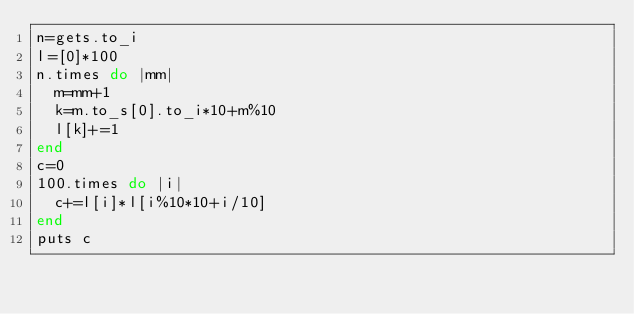<code> <loc_0><loc_0><loc_500><loc_500><_Ruby_>n=gets.to_i
l=[0]*100
n.times do |mm|
  m=mm+1
  k=m.to_s[0].to_i*10+m%10
  l[k]+=1
end
c=0
100.times do |i|
  c+=l[i]*l[i%10*10+i/10]
end
puts c
</code> 